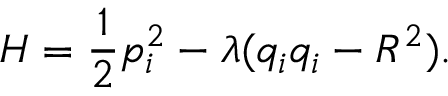<formula> <loc_0><loc_0><loc_500><loc_500>H = \frac { 1 } { 2 } p _ { i } ^ { 2 } - \lambda ( q _ { i } q _ { i } - R ^ { 2 } ) .</formula> 